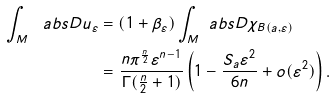Convert formula to latex. <formula><loc_0><loc_0><loc_500><loc_500>\int _ { M } \ a b s { D u _ { \varepsilon } } & = ( 1 + \beta _ { \varepsilon } ) \int _ { M } \ a b s { D \chi _ { B ( a , \varepsilon ) } } \\ & = \frac { n \pi ^ { \frac { n } { 2 } } \varepsilon ^ { n - 1 } } { \Gamma ( \frac { n } { 2 } + 1 ) } \left ( 1 - \frac { S _ { a } \varepsilon ^ { 2 } } { 6 n } + o ( \varepsilon ^ { 2 } ) \right ) .</formula> 